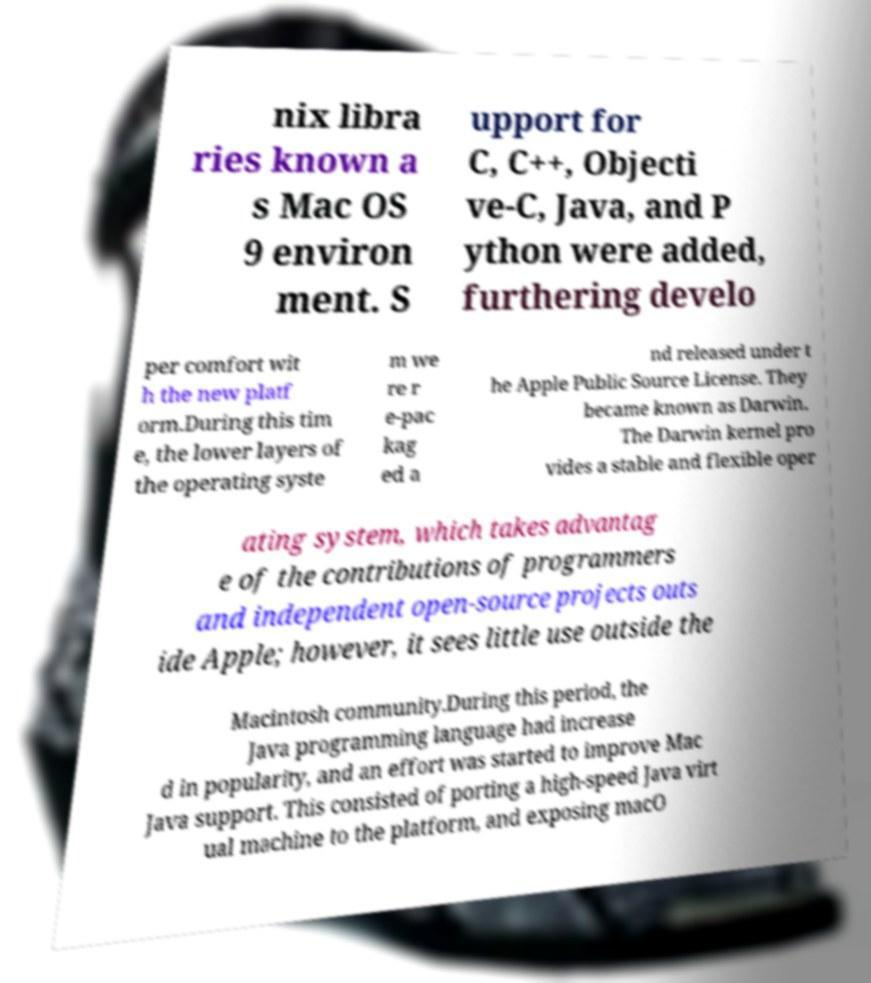Please identify and transcribe the text found in this image. nix libra ries known a s Mac OS 9 environ ment. S upport for C, C++, Objecti ve-C, Java, and P ython were added, furthering develo per comfort wit h the new platf orm.During this tim e, the lower layers of the operating syste m we re r e-pac kag ed a nd released under t he Apple Public Source License. They became known as Darwin. The Darwin kernel pro vides a stable and flexible oper ating system, which takes advantag e of the contributions of programmers and independent open-source projects outs ide Apple; however, it sees little use outside the Macintosh community.During this period, the Java programming language had increase d in popularity, and an effort was started to improve Mac Java support. This consisted of porting a high-speed Java virt ual machine to the platform, and exposing macO 